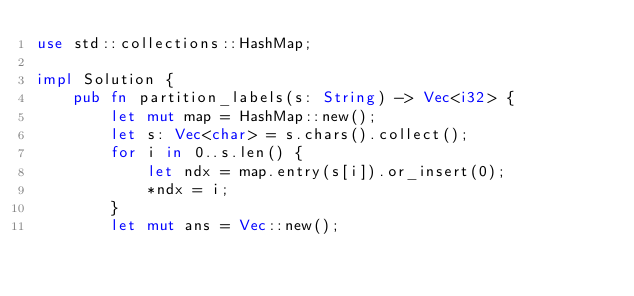Convert code to text. <code><loc_0><loc_0><loc_500><loc_500><_Rust_>use std::collections::HashMap;

impl Solution {
    pub fn partition_labels(s: String) -> Vec<i32> {
        let mut map = HashMap::new();
        let s: Vec<char> = s.chars().collect();
        for i in 0..s.len() {
            let ndx = map.entry(s[i]).or_insert(0);
            *ndx = i;
        }
        let mut ans = Vec::new();</code> 